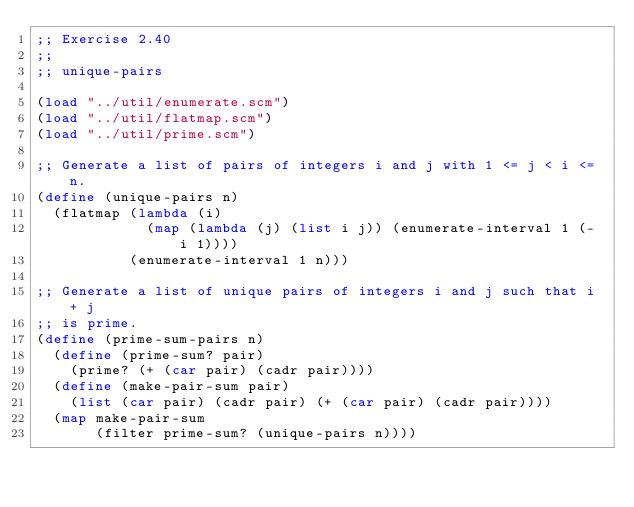<code> <loc_0><loc_0><loc_500><loc_500><_Scheme_>;; Exercise 2.40
;;
;; unique-pairs

(load "../util/enumerate.scm")
(load "../util/flatmap.scm")
(load "../util/prime.scm")

;; Generate a list of pairs of integers i and j with 1 <= j < i <= n.
(define (unique-pairs n)
  (flatmap (lambda (i)
             (map (lambda (j) (list i j)) (enumerate-interval 1 (- i 1))))
           (enumerate-interval 1 n)))

;; Generate a list of unique pairs of integers i and j such that i + j
;; is prime.
(define (prime-sum-pairs n)
  (define (prime-sum? pair)
    (prime? (+ (car pair) (cadr pair))))
  (define (make-pair-sum pair)
    (list (car pair) (cadr pair) (+ (car pair) (cadr pair))))
  (map make-pair-sum
       (filter prime-sum? (unique-pairs n))))
</code> 